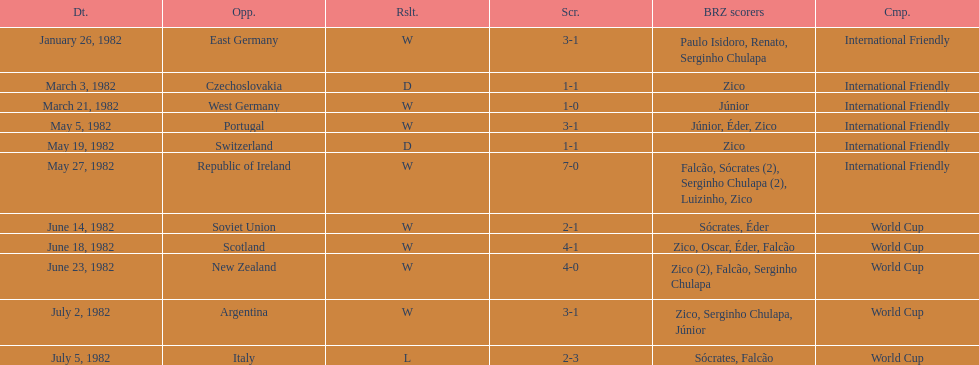Did brazil score more goals against the soviet union or portugal in 1982? Portugal. Parse the full table. {'header': ['Dt.', 'Opp.', 'Rslt.', 'Scr.', 'BRZ scorers', 'Cmp.'], 'rows': [['January 26, 1982', 'East Germany', 'W', '3-1', 'Paulo Isidoro, Renato, Serginho Chulapa', 'International Friendly'], ['March 3, 1982', 'Czechoslovakia', 'D', '1-1', 'Zico', 'International Friendly'], ['March 21, 1982', 'West Germany', 'W', '1-0', 'Júnior', 'International Friendly'], ['May 5, 1982', 'Portugal', 'W', '3-1', 'Júnior, Éder, Zico', 'International Friendly'], ['May 19, 1982', 'Switzerland', 'D', '1-1', 'Zico', 'International Friendly'], ['May 27, 1982', 'Republic of Ireland', 'W', '7-0', 'Falcão, Sócrates (2), Serginho Chulapa (2), Luizinho, Zico', 'International Friendly'], ['June 14, 1982', 'Soviet Union', 'W', '2-1', 'Sócrates, Éder', 'World Cup'], ['June 18, 1982', 'Scotland', 'W', '4-1', 'Zico, Oscar, Éder, Falcão', 'World Cup'], ['June 23, 1982', 'New Zealand', 'W', '4-0', 'Zico (2), Falcão, Serginho Chulapa', 'World Cup'], ['July 2, 1982', 'Argentina', 'W', '3-1', 'Zico, Serginho Chulapa, Júnior', 'World Cup'], ['July 5, 1982', 'Italy', 'L', '2-3', 'Sócrates, Falcão', 'World Cup']]} 